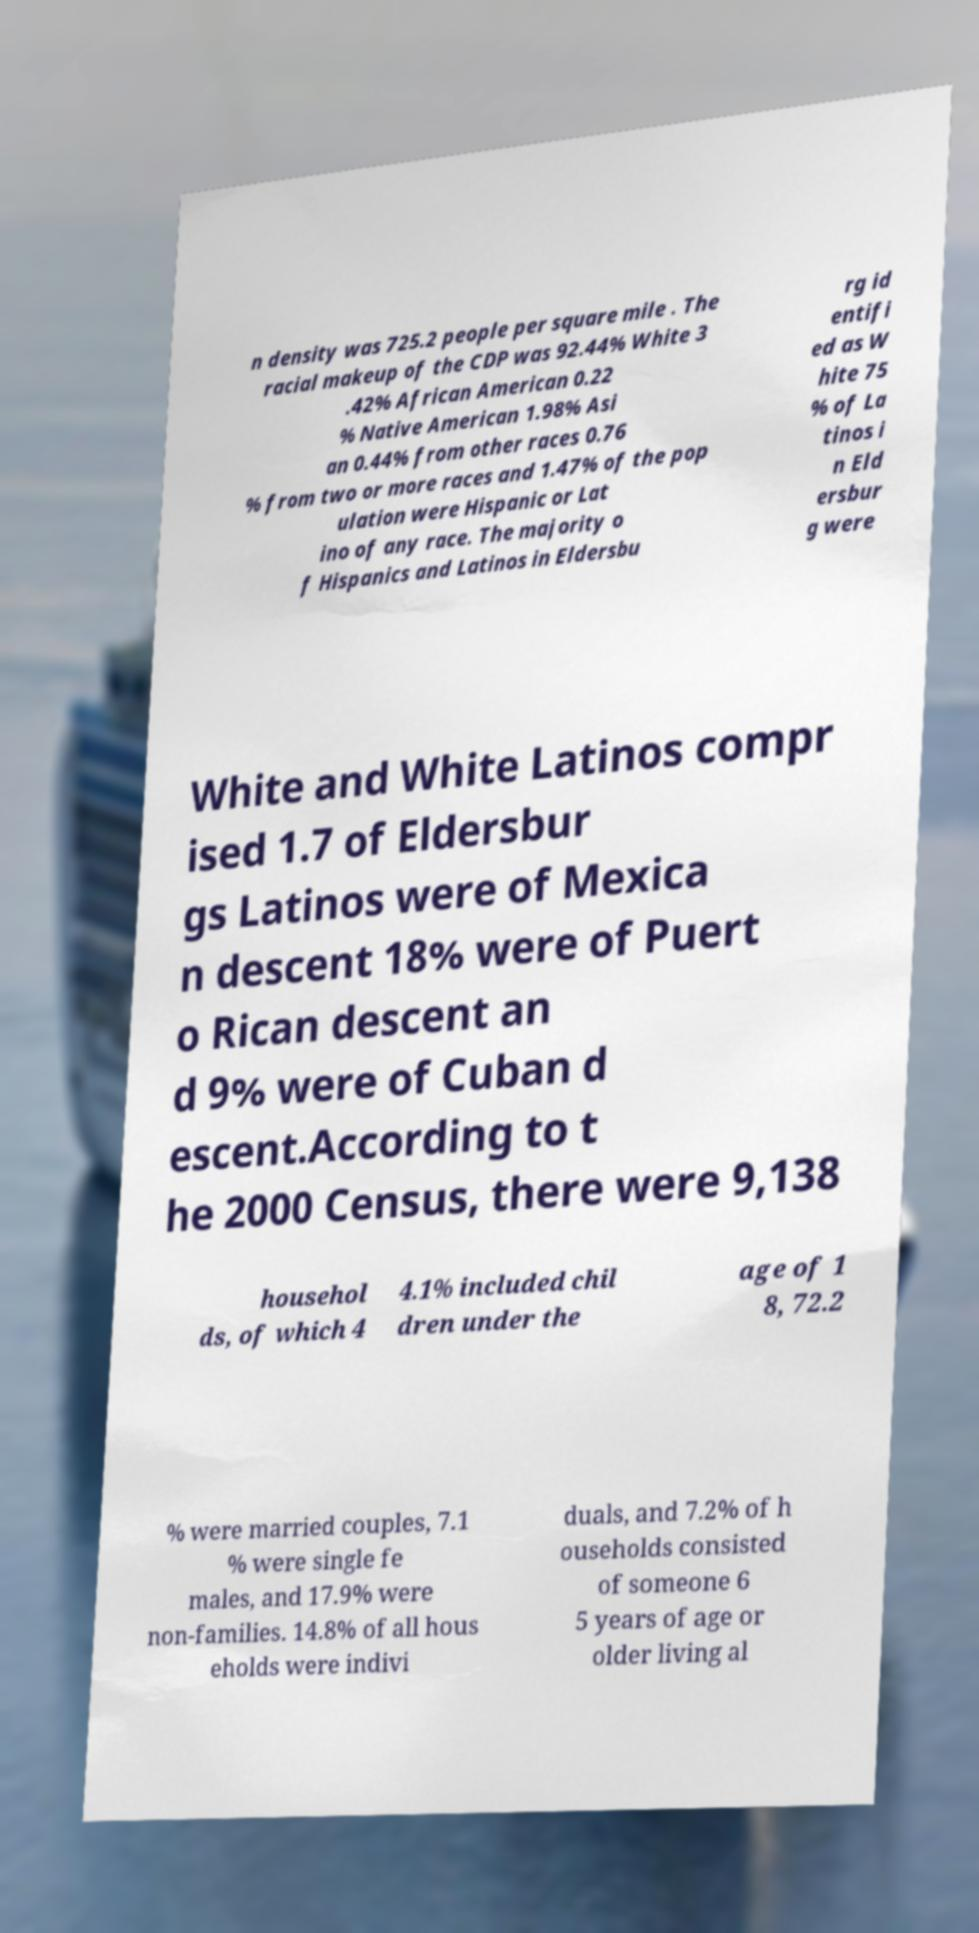For documentation purposes, I need the text within this image transcribed. Could you provide that? n density was 725.2 people per square mile . The racial makeup of the CDP was 92.44% White 3 .42% African American 0.22 % Native American 1.98% Asi an 0.44% from other races 0.76 % from two or more races and 1.47% of the pop ulation were Hispanic or Lat ino of any race. The majority o f Hispanics and Latinos in Eldersbu rg id entifi ed as W hite 75 % of La tinos i n Eld ersbur g were White and White Latinos compr ised 1.7 of Eldersbur gs Latinos were of Mexica n descent 18% were of Puert o Rican descent an d 9% were of Cuban d escent.According to t he 2000 Census, there were 9,138 househol ds, of which 4 4.1% included chil dren under the age of 1 8, 72.2 % were married couples, 7.1 % were single fe males, and 17.9% were non-families. 14.8% of all hous eholds were indivi duals, and 7.2% of h ouseholds consisted of someone 6 5 years of age or older living al 